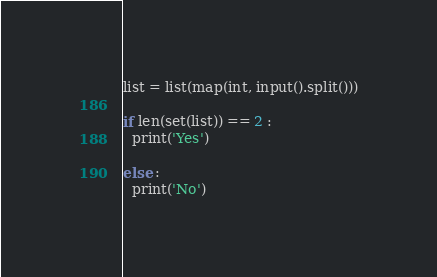<code> <loc_0><loc_0><loc_500><loc_500><_Python_>list = list(map(int, input().split()))

if len(set(list)) == 2 :
  print('Yes')
  
else :
  print('No')</code> 